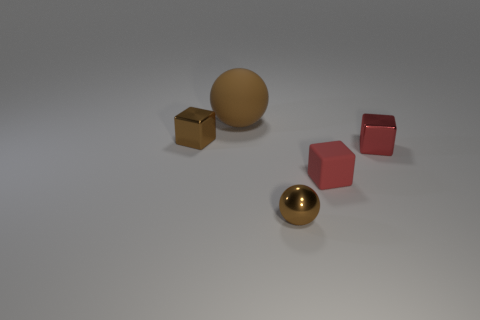Add 1 small matte things. How many objects exist? 6 Subtract all metallic blocks. How many blocks are left? 1 Subtract 1 cubes. How many cubes are left? 2 Subtract all balls. How many objects are left? 3 Add 4 small red cubes. How many small red cubes exist? 6 Subtract 0 cyan balls. How many objects are left? 5 Subtract all large yellow metallic objects. Subtract all big matte spheres. How many objects are left? 4 Add 2 brown shiny balls. How many brown shiny balls are left? 3 